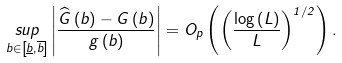Convert formula to latex. <formula><loc_0><loc_0><loc_500><loc_500>\underset { b \in \left [ \underline { b } , \overline { b } \right ] } { s u p } \left | \frac { \widehat { G } \left ( b \right ) - G \left ( b \right ) } { g \left ( b \right ) } \right | = O _ { p } \left ( \left ( \frac { \log \left ( L \right ) } { L } \right ) ^ { 1 / 2 } \right ) .</formula> 